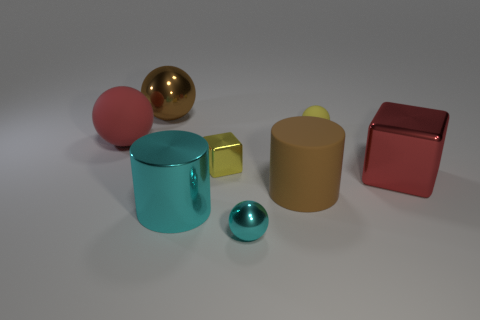Subtract all blue balls. Subtract all green cubes. How many balls are left? 4 Add 1 big brown shiny balls. How many objects exist? 9 Subtract all cylinders. How many objects are left? 6 Add 1 large shiny objects. How many large shiny objects are left? 4 Add 5 cyan things. How many cyan things exist? 7 Subtract 0 gray cylinders. How many objects are left? 8 Subtract all tiny blue matte objects. Subtract all large things. How many objects are left? 3 